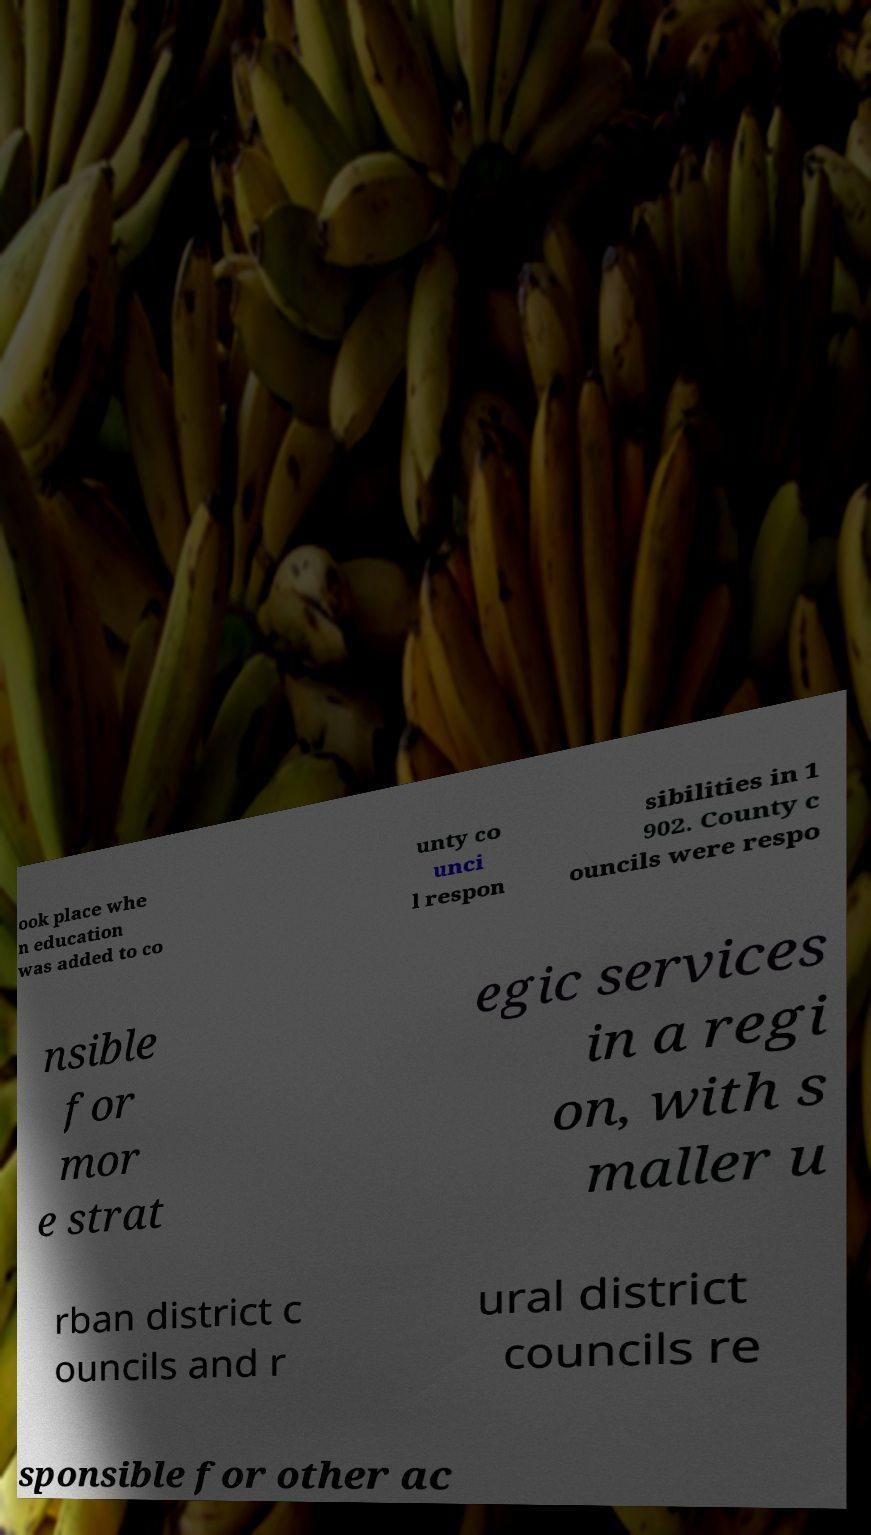Please identify and transcribe the text found in this image. ook place whe n education was added to co unty co unci l respon sibilities in 1 902. County c ouncils were respo nsible for mor e strat egic services in a regi on, with s maller u rban district c ouncils and r ural district councils re sponsible for other ac 